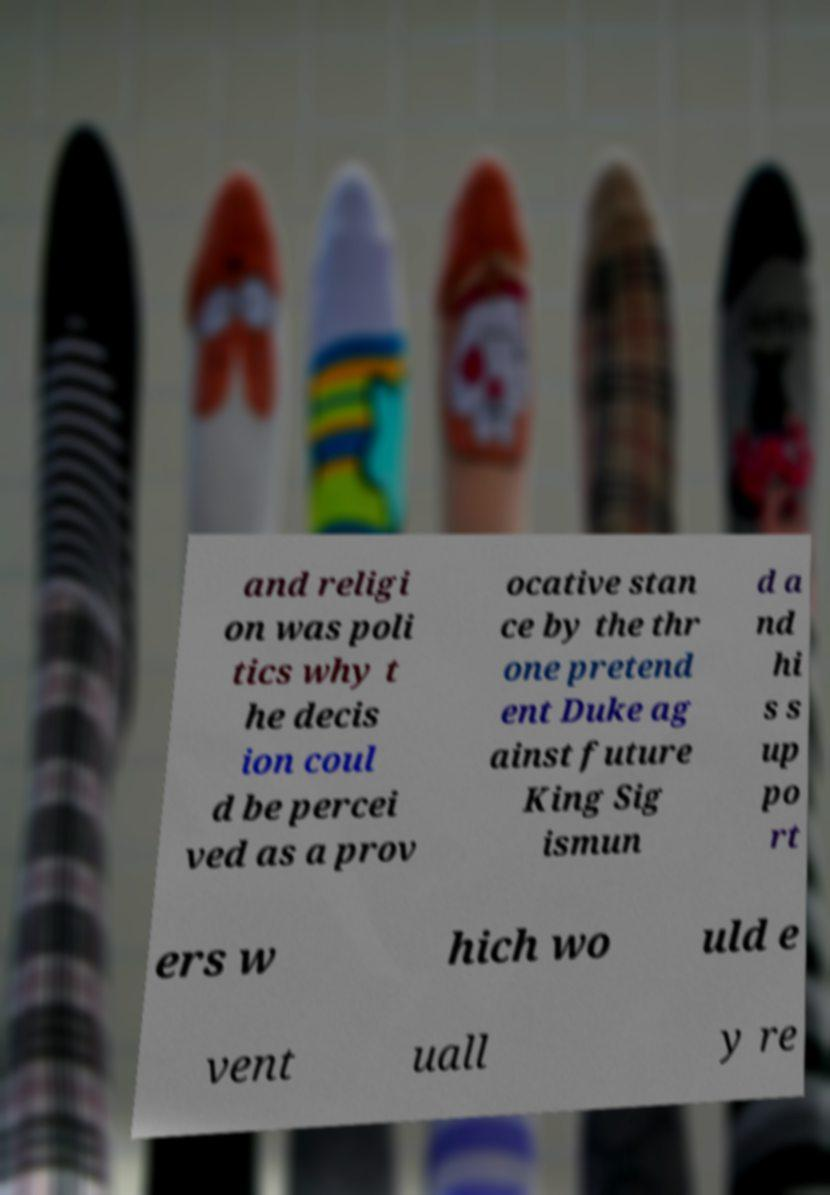For documentation purposes, I need the text within this image transcribed. Could you provide that? and religi on was poli tics why t he decis ion coul d be percei ved as a prov ocative stan ce by the thr one pretend ent Duke ag ainst future King Sig ismun d a nd hi s s up po rt ers w hich wo uld e vent uall y re 